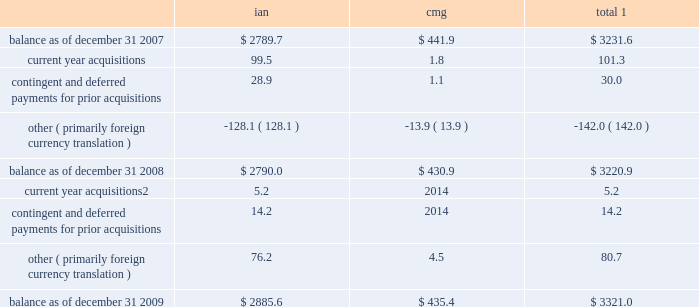Notes to consolidated financial statements 2014 ( continued ) ( amounts in millions , except per share amounts ) sales of businesses and investments 2013 primarily includes realized gains and losses relating to the sales of businesses , cumulative translation adjustment balances from the liquidation of entities and sales of marketable securities and investments in publicly traded and privately held companies in our rabbi trusts .
During 2009 , we realized a gain of $ 15.2 related to the sale of an investment in our rabbi trusts , which was partially offset by losses realized from the sale of various businesses .
Losses in 2007 primarily related to the sale of several businesses within draftfcb for a loss of $ 9.3 and charges at lowe of $ 7.8 as a result of the realization of cumulative translation adjustment balances from the liquidation of several businesses .
Vendor discounts and credit adjustments 2013 we are in the process of settling our liabilities related to vendor discounts and credits established during the restatement we presented in our 2004 annual report on form 10-k .
These adjustments reflect the reversal of certain of these liabilities as a result of settlements with clients or vendors or where the statute of limitations has lapsed .
Litigation settlement 2013 during may 2008 , the sec concluded its investigation that began in 2002 into our financial reporting practices , resulting in a settlement charge of $ 12.0 .
Investment impairments 2013 in 2007 we realized an other-than-temporary charge of $ 5.8 relating to a $ 12.5 investment in auction rate securities , representing our total investment in auction rate securities .
See note 12 for further information .
Note 5 : intangible assets goodwill goodwill is the excess purchase price remaining from an acquisition after an allocation of purchase price has been made to identifiable assets acquired and liabilities assumed based on estimated fair values .
The changes in the carrying value of goodwill for our segments , integrated agency networks ( 201cian 201d ) and constituency management group ( 201ccmg 201d ) , for the years ended december 31 , 2009 and 2008 are listed below. .
1 for all periods presented we have not recorded a goodwill impairment charge .
2 for acquisitions completed after january 1 , 2009 , amount includes contingent and deferred payments , which are recorded at fair value on the acquisition date .
See note 6 for further information .
See note 1 for further information regarding our annual impairment methodology .
Other intangible assets included in other intangible assets are assets with indefinite lives not subject to amortization and assets with definite lives subject to amortization .
Other intangible assets primarily include customer lists and trade names .
Intangible assets with definitive lives subject to amortization are amortized on a straight-line basis with estimated useful lives generally between 7 and 15 years .
Amortization expense for other intangible assets for the years ended december 31 , 2009 , 2008 and 2007 was $ 19.3 , $ 14.4 and $ 8.5 , respectively .
The following table provides a summary of other intangible assets , which are included in other assets on our consolidated balance sheets. .
What was the percentage change in the carrying value of goodwill for integrated agency networks from 2008 to 2009? 
Computations: ((2885.6 - 2790.0) / 2790.0)
Answer: 0.03427. 